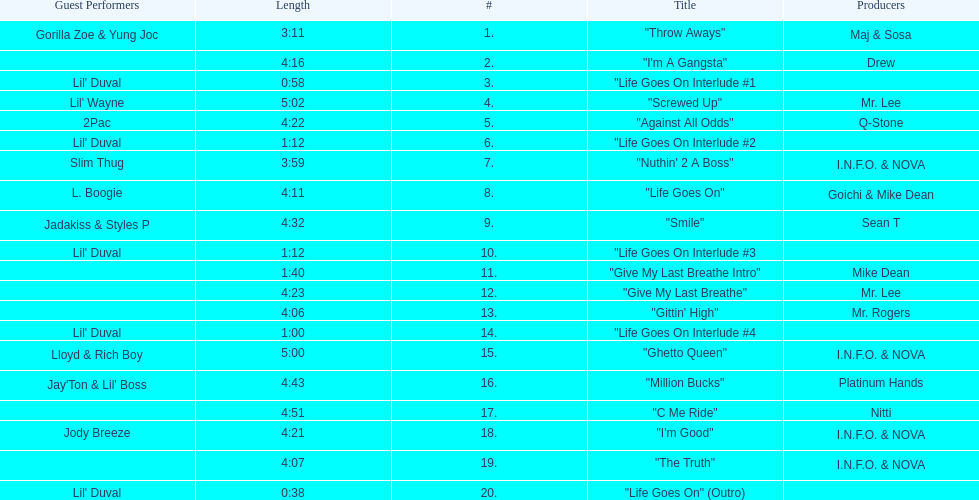How long is the longest track on the album? 5:02. 